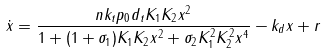<formula> <loc_0><loc_0><loc_500><loc_500>\dot { x } = \frac { n k _ { t } p _ { 0 } d _ { t } K _ { 1 } K _ { 2 } x ^ { 2 } } { 1 + ( 1 + \sigma _ { 1 } ) K _ { 1 } K _ { 2 } x ^ { 2 } + \sigma _ { 2 } K _ { 1 } ^ { 2 } K _ { 2 } ^ { 2 } x ^ { 4 } } - k _ { d } x + r</formula> 